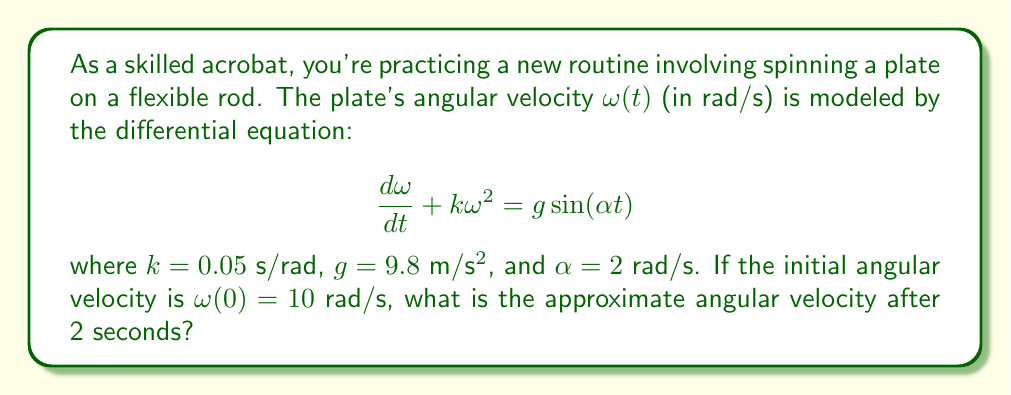Could you help me with this problem? To solve this nonlinear differential equation, we'll use a numerical method called Euler's method. Here's the step-by-step process:

1) Euler's method approximates the solution using the formula:
   $$\omega_{n+1} = \omega_n + h \cdot f(t_n, \omega_n)$$
   where $h$ is the step size and $f(t, \omega) = g\sin(\alpha t) - k\omega^2$

2) Let's use a step size of $h = 0.1$ s. We need to calculate 20 steps to reach 2 seconds.

3) Initial conditions: $t_0 = 0$, $\omega_0 = 10$

4) For each step, we calculate:
   $$\omega_{n+1} = \omega_n + 0.1 \cdot (9.8\sin(2t_n) - 0.05\omega_n^2)$$

5) Here are the first few steps:
   $\omega_1 = 10 + 0.1 \cdot (9.8\sin(0) - 0.05 \cdot 10^2) = 9.5$
   $\omega_2 = 9.5 + 0.1 \cdot (9.8\sin(0.2) - 0.05 \cdot 9.5^2) = 9.0325$
   $\omega_3 = 9.0325 + 0.1 \cdot (9.8\sin(0.4) - 0.05 \cdot 9.0325^2) = 8.6075$

6) Continuing this process for 20 steps (which can be done easily with a computer or calculator), we arrive at the final value.

7) After 2 seconds (20 steps), the angular velocity is approximately 6.8721 rad/s.
Answer: 6.87 rad/s 